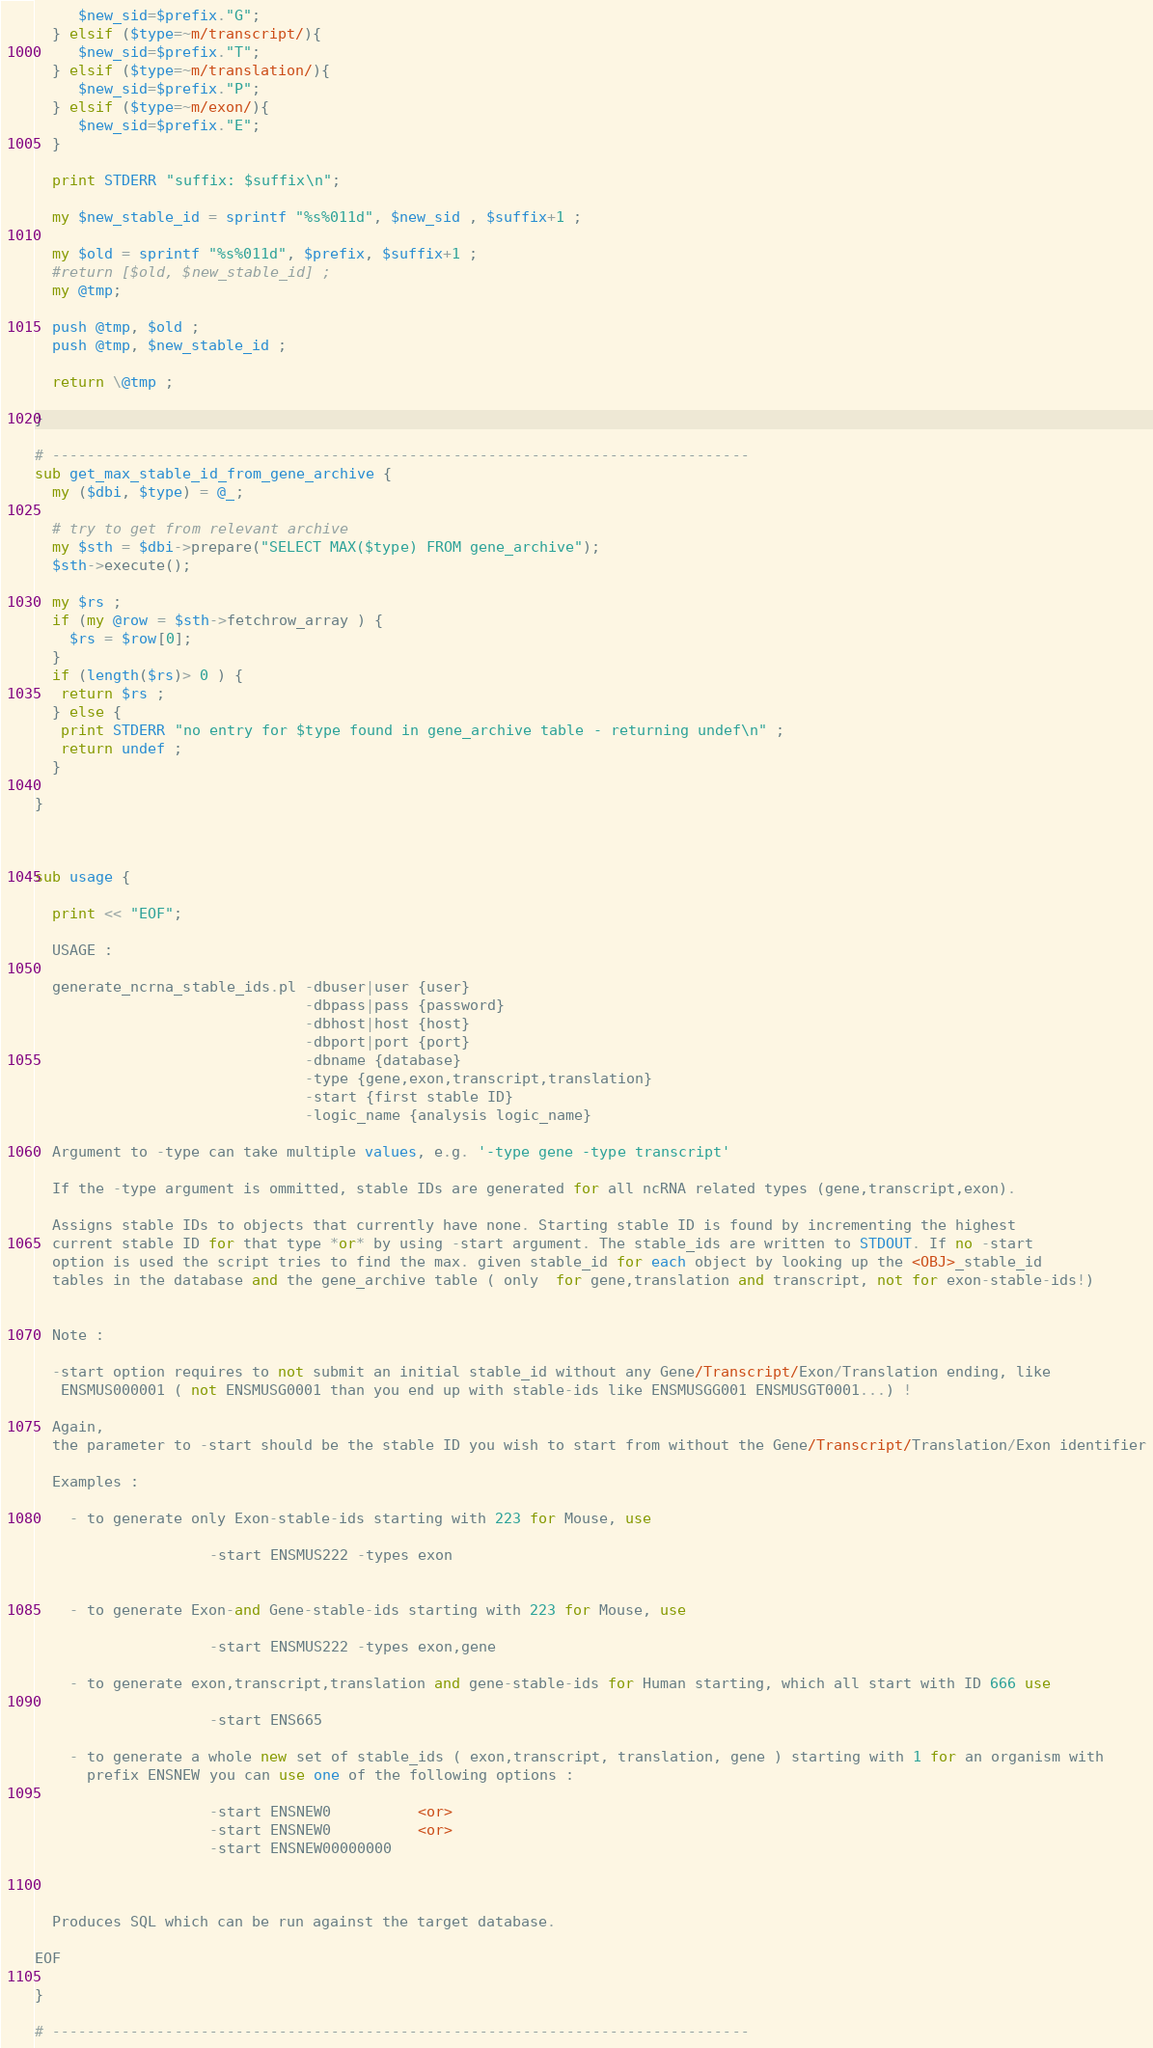Convert code to text. <code><loc_0><loc_0><loc_500><loc_500><_Perl_>     $new_sid=$prefix."G"; 
  } elsif ($type=~m/transcript/){ 
     $new_sid=$prefix."T";
  } elsif ($type=~m/translation/){ 
     $new_sid=$prefix."P";
  } elsif ($type=~m/exon/){ 
     $new_sid=$prefix."E";
  }

  print STDERR "suffix: $suffix\n";

  my $new_stable_id = sprintf "%s%011d", $new_sid , $suffix+1 ;   

  my $old = sprintf "%s%011d", $prefix, $suffix+1 ;    
  #return [$old, $new_stable_id] ; 
  my @tmp;  
  
  push @tmp, $old ; 
  push @tmp, $new_stable_id ;  
 
  return \@tmp ; 

}

# -------------------------------------------------------------------------------- 
sub get_max_stable_id_from_gene_archive { 
  my ($dbi, $type) = @_;   

  # try to get from relevant archive
  my $sth = $dbi->prepare("SELECT MAX($type) FROM gene_archive");
  $sth->execute();  

  my $rs ;  
  if (my @row = $sth->fetchrow_array ) { 
    $rs = $row[0];
  }  
  if (length($rs)> 0 ) { 
   return $rs ; 
  } else { 
   print STDERR "no entry for $type found in gene_archive table - returning undef\n" ;  
   return undef ;
  }  

} 



sub usage {

  print << "EOF";

  USAGE :  

  generate_ncrna_stable_ids.pl -dbuser|user {user} 
                               -dbpass|pass {password} 
                               -dbhost|host {host}
                               -dbport|port {port} 
                               -dbname {database} 
                               -type {gene,exon,transcript,translation} 
                               -start {first stable ID}
                               -logic_name {analysis logic_name}

  Argument to -type can take multiple values, e.g. '-type gene -type transcript'

  If the -type argument is ommitted, stable IDs are generated for all ncRNA related types (gene,transcript,exon).

  Assigns stable IDs to objects that currently have none. Starting stable ID is found by incrementing the highest 
  current stable ID for that type *or* by using -start argument. The stable_ids are written to STDOUT. If no -start
  option is used the script tries to find the max. given stable_id for each object by looking up the <OBJ>_stable_id
  tables in the database and the gene_archive table ( only  for gene,translation and transcript, not for exon-stable-ids!)


  Note : 

  -start option requires to not submit an initial stable_id without any Gene/Transcript/Exon/Translation ending, like 
   ENSMUS000001 ( not ENSMUSG0001 than you end up with stable-ids like ENSMUSGG001 ENSMUSGT0001...) !

  Again,
  the parameter to -start should be the stable ID you wish to start from without the Gene/Transcript/Translation/Exon identifier

  Examples :  

    - to generate only Exon-stable-ids starting with 223 for Mouse, use 

                    -start ENSMUS222 -types exon 


    - to generate Exon-and Gene-stable-ids starting with 223 for Mouse, use 

                    -start ENSMUS222 -types exon,gene

    - to generate exon,transcript,translation and gene-stable-ids for Human starting, which all start with ID 666 use 

                    -start ENS665     

    - to generate a whole new set of stable_ids ( exon,transcript, translation, gene ) starting with 1 for an organism with 
      prefix ENSNEW you can use one of the following options : 
             
                    -start ENSNEW0          <or> 
                    -start ENSNEW0          <or> 
                    -start ENSNEW00000000
             


  Produces SQL which can be run against the target database.

EOF

}

# --------------------------------------------------------------------------------
</code> 